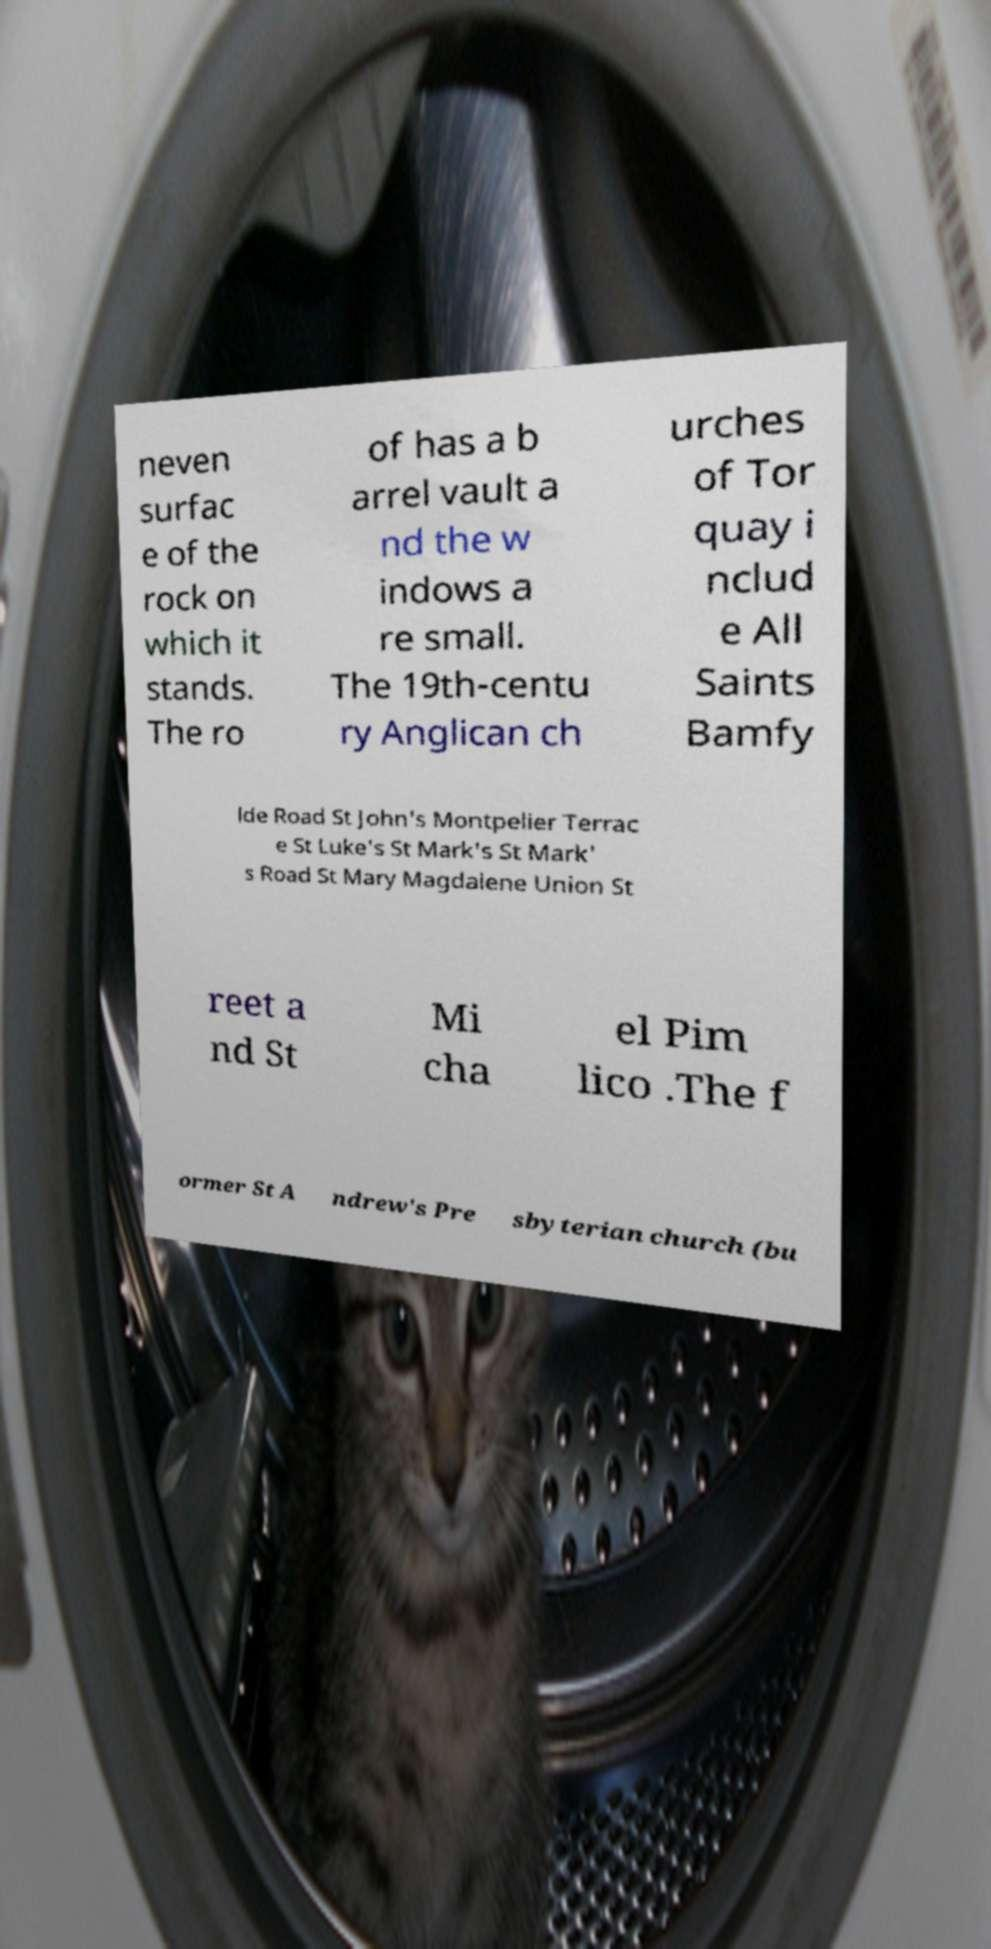Please identify and transcribe the text found in this image. neven surfac e of the rock on which it stands. The ro of has a b arrel vault a nd the w indows a re small. The 19th-centu ry Anglican ch urches of Tor quay i nclud e All Saints Bamfy lde Road St John's Montpelier Terrac e St Luke's St Mark's St Mark' s Road St Mary Magdalene Union St reet a nd St Mi cha el Pim lico .The f ormer St A ndrew's Pre sbyterian church (bu 